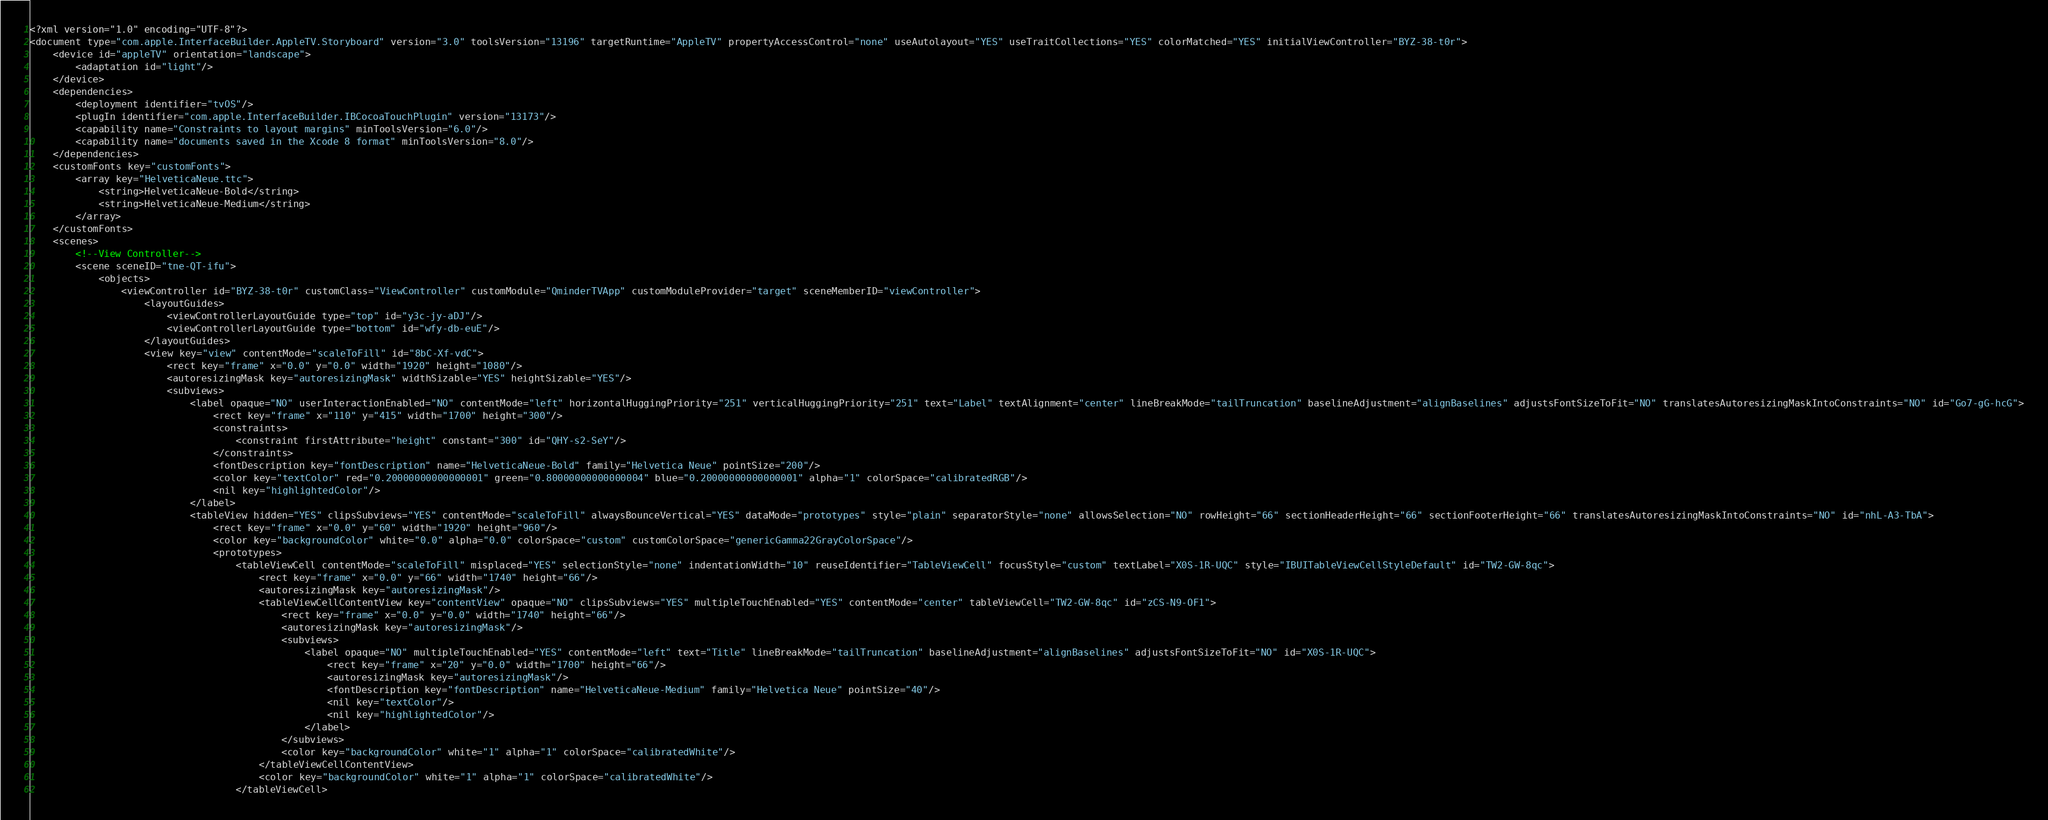Convert code to text. <code><loc_0><loc_0><loc_500><loc_500><_XML_><?xml version="1.0" encoding="UTF-8"?>
<document type="com.apple.InterfaceBuilder.AppleTV.Storyboard" version="3.0" toolsVersion="13196" targetRuntime="AppleTV" propertyAccessControl="none" useAutolayout="YES" useTraitCollections="YES" colorMatched="YES" initialViewController="BYZ-38-t0r">
    <device id="appleTV" orientation="landscape">
        <adaptation id="light"/>
    </device>
    <dependencies>
        <deployment identifier="tvOS"/>
        <plugIn identifier="com.apple.InterfaceBuilder.IBCocoaTouchPlugin" version="13173"/>
        <capability name="Constraints to layout margins" minToolsVersion="6.0"/>
        <capability name="documents saved in the Xcode 8 format" minToolsVersion="8.0"/>
    </dependencies>
    <customFonts key="customFonts">
        <array key="HelveticaNeue.ttc">
            <string>HelveticaNeue-Bold</string>
            <string>HelveticaNeue-Medium</string>
        </array>
    </customFonts>
    <scenes>
        <!--View Controller-->
        <scene sceneID="tne-QT-ifu">
            <objects>
                <viewController id="BYZ-38-t0r" customClass="ViewController" customModule="QminderTVApp" customModuleProvider="target" sceneMemberID="viewController">
                    <layoutGuides>
                        <viewControllerLayoutGuide type="top" id="y3c-jy-aDJ"/>
                        <viewControllerLayoutGuide type="bottom" id="wfy-db-euE"/>
                    </layoutGuides>
                    <view key="view" contentMode="scaleToFill" id="8bC-Xf-vdC">
                        <rect key="frame" x="0.0" y="0.0" width="1920" height="1080"/>
                        <autoresizingMask key="autoresizingMask" widthSizable="YES" heightSizable="YES"/>
                        <subviews>
                            <label opaque="NO" userInteractionEnabled="NO" contentMode="left" horizontalHuggingPriority="251" verticalHuggingPriority="251" text="Label" textAlignment="center" lineBreakMode="tailTruncation" baselineAdjustment="alignBaselines" adjustsFontSizeToFit="NO" translatesAutoresizingMaskIntoConstraints="NO" id="Go7-gG-hcG">
                                <rect key="frame" x="110" y="415" width="1700" height="300"/>
                                <constraints>
                                    <constraint firstAttribute="height" constant="300" id="QHY-s2-SeY"/>
                                </constraints>
                                <fontDescription key="fontDescription" name="HelveticaNeue-Bold" family="Helvetica Neue" pointSize="200"/>
                                <color key="textColor" red="0.20000000000000001" green="0.80000000000000004" blue="0.20000000000000001" alpha="1" colorSpace="calibratedRGB"/>
                                <nil key="highlightedColor"/>
                            </label>
                            <tableView hidden="YES" clipsSubviews="YES" contentMode="scaleToFill" alwaysBounceVertical="YES" dataMode="prototypes" style="plain" separatorStyle="none" allowsSelection="NO" rowHeight="66" sectionHeaderHeight="66" sectionFooterHeight="66" translatesAutoresizingMaskIntoConstraints="NO" id="nhL-A3-TbA">
                                <rect key="frame" x="0.0" y="60" width="1920" height="960"/>
                                <color key="backgroundColor" white="0.0" alpha="0.0" colorSpace="custom" customColorSpace="genericGamma22GrayColorSpace"/>
                                <prototypes>
                                    <tableViewCell contentMode="scaleToFill" misplaced="YES" selectionStyle="none" indentationWidth="10" reuseIdentifier="TableViewCell" focusStyle="custom" textLabel="X0S-1R-UQC" style="IBUITableViewCellStyleDefault" id="TW2-GW-8qc">
                                        <rect key="frame" x="0.0" y="66" width="1740" height="66"/>
                                        <autoresizingMask key="autoresizingMask"/>
                                        <tableViewCellContentView key="contentView" opaque="NO" clipsSubviews="YES" multipleTouchEnabled="YES" contentMode="center" tableViewCell="TW2-GW-8qc" id="zCS-N9-OF1">
                                            <rect key="frame" x="0.0" y="0.0" width="1740" height="66"/>
                                            <autoresizingMask key="autoresizingMask"/>
                                            <subviews>
                                                <label opaque="NO" multipleTouchEnabled="YES" contentMode="left" text="Title" lineBreakMode="tailTruncation" baselineAdjustment="alignBaselines" adjustsFontSizeToFit="NO" id="X0S-1R-UQC">
                                                    <rect key="frame" x="20" y="0.0" width="1700" height="66"/>
                                                    <autoresizingMask key="autoresizingMask"/>
                                                    <fontDescription key="fontDescription" name="HelveticaNeue-Medium" family="Helvetica Neue" pointSize="40"/>
                                                    <nil key="textColor"/>
                                                    <nil key="highlightedColor"/>
                                                </label>
                                            </subviews>
                                            <color key="backgroundColor" white="1" alpha="1" colorSpace="calibratedWhite"/>
                                        </tableViewCellContentView>
                                        <color key="backgroundColor" white="1" alpha="1" colorSpace="calibratedWhite"/>
                                    </tableViewCell></code> 